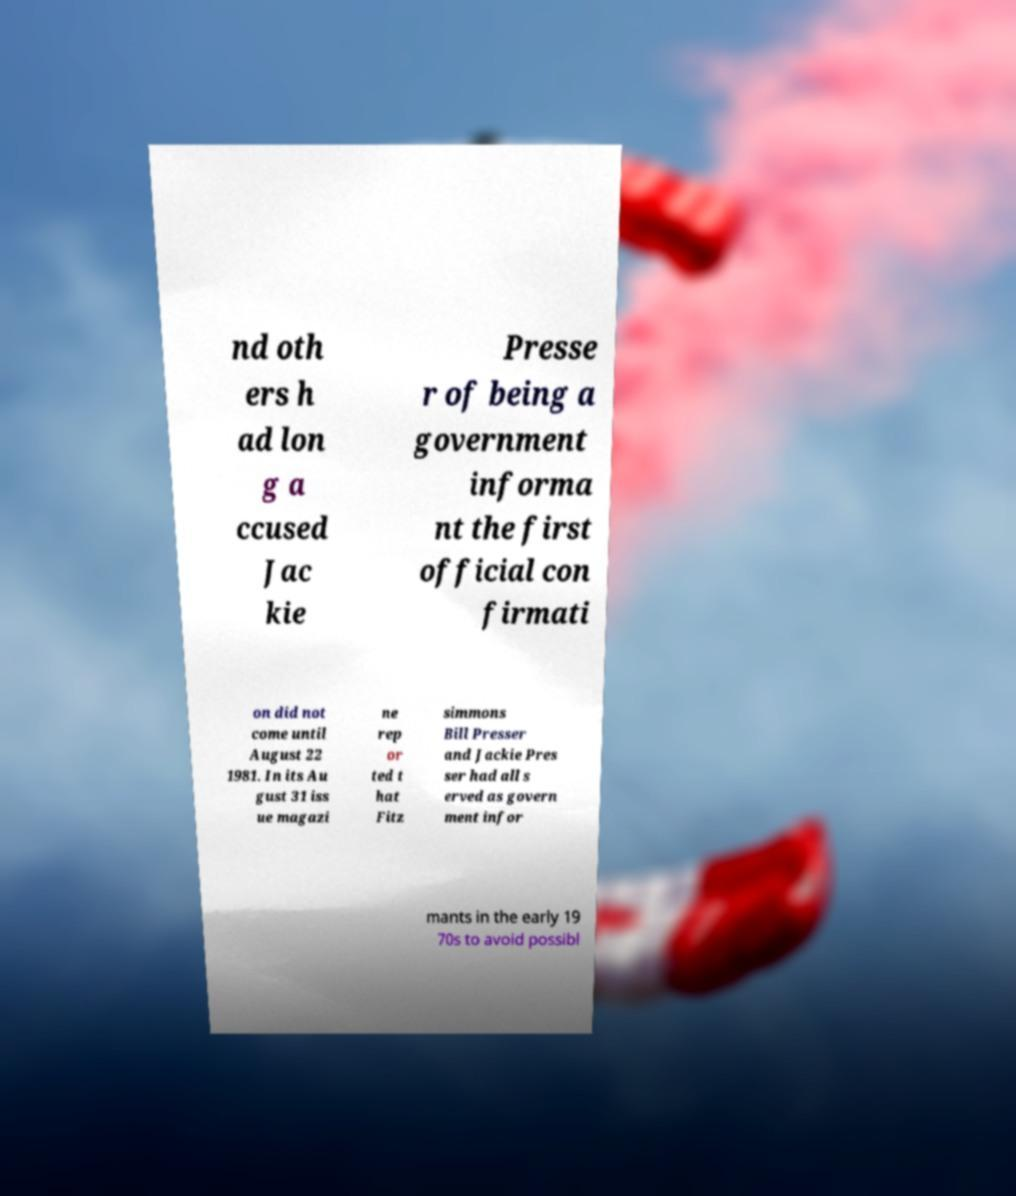Please identify and transcribe the text found in this image. nd oth ers h ad lon g a ccused Jac kie Presse r of being a government informa nt the first official con firmati on did not come until August 22 1981. In its Au gust 31 iss ue magazi ne rep or ted t hat Fitz simmons Bill Presser and Jackie Pres ser had all s erved as govern ment infor mants in the early 19 70s to avoid possibl 